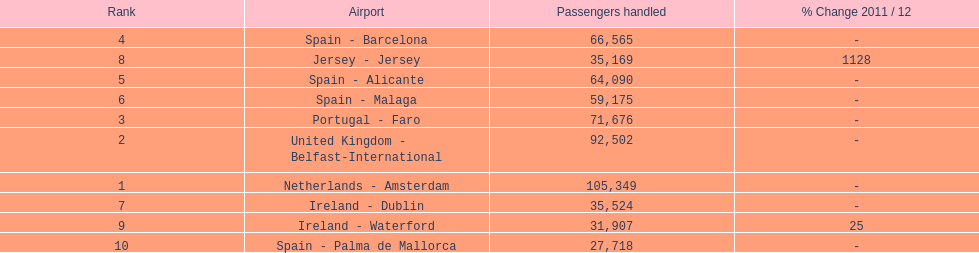Which airport had more passengers handled than the united kingdom? Netherlands - Amsterdam. 